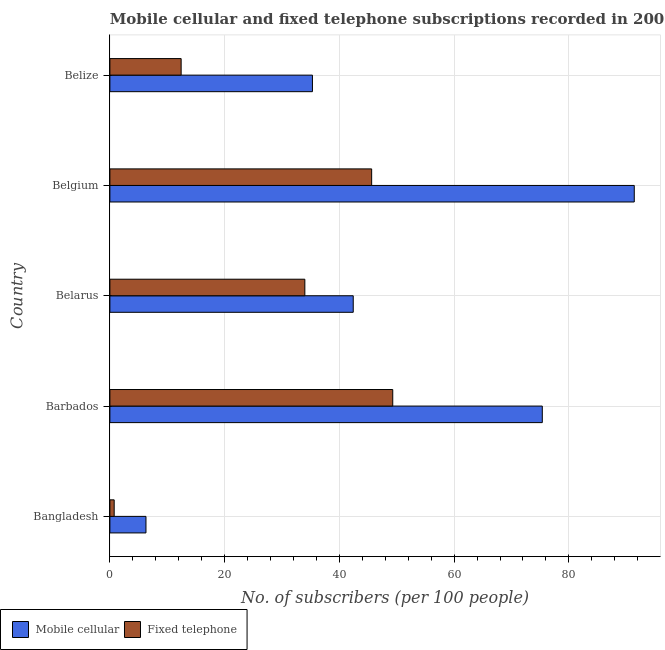How many different coloured bars are there?
Offer a very short reply. 2. Are the number of bars on each tick of the Y-axis equal?
Ensure brevity in your answer.  Yes. How many bars are there on the 4th tick from the bottom?
Keep it short and to the point. 2. What is the label of the 4th group of bars from the top?
Offer a terse response. Barbados. What is the number of fixed telephone subscribers in Bangladesh?
Your response must be concise. 0.75. Across all countries, what is the maximum number of fixed telephone subscribers?
Keep it short and to the point. 49.3. Across all countries, what is the minimum number of fixed telephone subscribers?
Keep it short and to the point. 0.75. In which country was the number of fixed telephone subscribers maximum?
Provide a succinct answer. Barbados. What is the total number of fixed telephone subscribers in the graph?
Your answer should be compact. 142.08. What is the difference between the number of mobile cellular subscribers in Bangladesh and that in Belize?
Provide a succinct answer. -29.02. What is the difference between the number of mobile cellular subscribers in Bangladesh and the number of fixed telephone subscribers in Belarus?
Provide a succinct answer. -27.69. What is the average number of fixed telephone subscribers per country?
Give a very brief answer. 28.42. What is the difference between the number of fixed telephone subscribers and number of mobile cellular subscribers in Belgium?
Your answer should be very brief. -45.77. What is the ratio of the number of mobile cellular subscribers in Bangladesh to that in Belize?
Make the answer very short. 0.18. What is the difference between the highest and the second highest number of fixed telephone subscribers?
Keep it short and to the point. 3.68. What is the difference between the highest and the lowest number of mobile cellular subscribers?
Provide a short and direct response. 85.12. In how many countries, is the number of fixed telephone subscribers greater than the average number of fixed telephone subscribers taken over all countries?
Make the answer very short. 3. Is the sum of the number of fixed telephone subscribers in Barbados and Belgium greater than the maximum number of mobile cellular subscribers across all countries?
Your answer should be compact. Yes. What does the 1st bar from the top in Barbados represents?
Provide a short and direct response. Fixed telephone. What does the 1st bar from the bottom in Belize represents?
Ensure brevity in your answer.  Mobile cellular. How many bars are there?
Offer a very short reply. 10. Are the values on the major ticks of X-axis written in scientific E-notation?
Keep it short and to the point. No. Does the graph contain grids?
Keep it short and to the point. Yes. Where does the legend appear in the graph?
Offer a terse response. Bottom left. How are the legend labels stacked?
Your answer should be very brief. Horizontal. What is the title of the graph?
Provide a short and direct response. Mobile cellular and fixed telephone subscriptions recorded in 2005. What is the label or title of the X-axis?
Offer a terse response. No. of subscribers (per 100 people). What is the No. of subscribers (per 100 people) of Mobile cellular in Bangladesh?
Your answer should be very brief. 6.29. What is the No. of subscribers (per 100 people) in Fixed telephone in Bangladesh?
Keep it short and to the point. 0.75. What is the No. of subscribers (per 100 people) in Mobile cellular in Barbados?
Offer a very short reply. 75.37. What is the No. of subscribers (per 100 people) in Fixed telephone in Barbados?
Keep it short and to the point. 49.3. What is the No. of subscribers (per 100 people) of Mobile cellular in Belarus?
Offer a terse response. 42.42. What is the No. of subscribers (per 100 people) of Fixed telephone in Belarus?
Keep it short and to the point. 33.98. What is the No. of subscribers (per 100 people) of Mobile cellular in Belgium?
Give a very brief answer. 91.4. What is the No. of subscribers (per 100 people) of Fixed telephone in Belgium?
Make the answer very short. 45.63. What is the No. of subscribers (per 100 people) in Mobile cellular in Belize?
Keep it short and to the point. 35.3. What is the No. of subscribers (per 100 people) in Fixed telephone in Belize?
Offer a terse response. 12.42. Across all countries, what is the maximum No. of subscribers (per 100 people) of Mobile cellular?
Your answer should be very brief. 91.4. Across all countries, what is the maximum No. of subscribers (per 100 people) in Fixed telephone?
Your answer should be compact. 49.3. Across all countries, what is the minimum No. of subscribers (per 100 people) of Mobile cellular?
Your answer should be very brief. 6.29. Across all countries, what is the minimum No. of subscribers (per 100 people) of Fixed telephone?
Your response must be concise. 0.75. What is the total No. of subscribers (per 100 people) in Mobile cellular in the graph?
Offer a very short reply. 250.78. What is the total No. of subscribers (per 100 people) of Fixed telephone in the graph?
Your answer should be very brief. 142.08. What is the difference between the No. of subscribers (per 100 people) of Mobile cellular in Bangladesh and that in Barbados?
Your answer should be compact. -69.08. What is the difference between the No. of subscribers (per 100 people) of Fixed telephone in Bangladesh and that in Barbados?
Give a very brief answer. -48.56. What is the difference between the No. of subscribers (per 100 people) in Mobile cellular in Bangladesh and that in Belarus?
Offer a terse response. -36.13. What is the difference between the No. of subscribers (per 100 people) of Fixed telephone in Bangladesh and that in Belarus?
Provide a short and direct response. -33.23. What is the difference between the No. of subscribers (per 100 people) of Mobile cellular in Bangladesh and that in Belgium?
Make the answer very short. -85.12. What is the difference between the No. of subscribers (per 100 people) in Fixed telephone in Bangladesh and that in Belgium?
Offer a very short reply. -44.88. What is the difference between the No. of subscribers (per 100 people) in Mobile cellular in Bangladesh and that in Belize?
Give a very brief answer. -29.02. What is the difference between the No. of subscribers (per 100 people) of Fixed telephone in Bangladesh and that in Belize?
Provide a succinct answer. -11.67. What is the difference between the No. of subscribers (per 100 people) in Mobile cellular in Barbados and that in Belarus?
Provide a short and direct response. 32.95. What is the difference between the No. of subscribers (per 100 people) in Fixed telephone in Barbados and that in Belarus?
Ensure brevity in your answer.  15.32. What is the difference between the No. of subscribers (per 100 people) of Mobile cellular in Barbados and that in Belgium?
Your response must be concise. -16.03. What is the difference between the No. of subscribers (per 100 people) in Fixed telephone in Barbados and that in Belgium?
Offer a very short reply. 3.68. What is the difference between the No. of subscribers (per 100 people) in Mobile cellular in Barbados and that in Belize?
Your response must be concise. 40.07. What is the difference between the No. of subscribers (per 100 people) of Fixed telephone in Barbados and that in Belize?
Offer a very short reply. 36.88. What is the difference between the No. of subscribers (per 100 people) in Mobile cellular in Belarus and that in Belgium?
Your response must be concise. -48.99. What is the difference between the No. of subscribers (per 100 people) in Fixed telephone in Belarus and that in Belgium?
Your answer should be compact. -11.65. What is the difference between the No. of subscribers (per 100 people) in Mobile cellular in Belarus and that in Belize?
Keep it short and to the point. 7.11. What is the difference between the No. of subscribers (per 100 people) in Fixed telephone in Belarus and that in Belize?
Make the answer very short. 21.56. What is the difference between the No. of subscribers (per 100 people) of Mobile cellular in Belgium and that in Belize?
Your answer should be very brief. 56.1. What is the difference between the No. of subscribers (per 100 people) in Fixed telephone in Belgium and that in Belize?
Give a very brief answer. 33.21. What is the difference between the No. of subscribers (per 100 people) in Mobile cellular in Bangladesh and the No. of subscribers (per 100 people) in Fixed telephone in Barbados?
Provide a short and direct response. -43.02. What is the difference between the No. of subscribers (per 100 people) in Mobile cellular in Bangladesh and the No. of subscribers (per 100 people) in Fixed telephone in Belarus?
Ensure brevity in your answer.  -27.69. What is the difference between the No. of subscribers (per 100 people) in Mobile cellular in Bangladesh and the No. of subscribers (per 100 people) in Fixed telephone in Belgium?
Give a very brief answer. -39.34. What is the difference between the No. of subscribers (per 100 people) of Mobile cellular in Bangladesh and the No. of subscribers (per 100 people) of Fixed telephone in Belize?
Provide a succinct answer. -6.13. What is the difference between the No. of subscribers (per 100 people) in Mobile cellular in Barbados and the No. of subscribers (per 100 people) in Fixed telephone in Belarus?
Your answer should be compact. 41.39. What is the difference between the No. of subscribers (per 100 people) of Mobile cellular in Barbados and the No. of subscribers (per 100 people) of Fixed telephone in Belgium?
Offer a terse response. 29.74. What is the difference between the No. of subscribers (per 100 people) of Mobile cellular in Barbados and the No. of subscribers (per 100 people) of Fixed telephone in Belize?
Keep it short and to the point. 62.95. What is the difference between the No. of subscribers (per 100 people) in Mobile cellular in Belarus and the No. of subscribers (per 100 people) in Fixed telephone in Belgium?
Keep it short and to the point. -3.21. What is the difference between the No. of subscribers (per 100 people) of Mobile cellular in Belarus and the No. of subscribers (per 100 people) of Fixed telephone in Belize?
Your answer should be compact. 30. What is the difference between the No. of subscribers (per 100 people) in Mobile cellular in Belgium and the No. of subscribers (per 100 people) in Fixed telephone in Belize?
Offer a very short reply. 78.98. What is the average No. of subscribers (per 100 people) in Mobile cellular per country?
Your answer should be compact. 50.16. What is the average No. of subscribers (per 100 people) of Fixed telephone per country?
Keep it short and to the point. 28.42. What is the difference between the No. of subscribers (per 100 people) of Mobile cellular and No. of subscribers (per 100 people) of Fixed telephone in Bangladesh?
Provide a succinct answer. 5.54. What is the difference between the No. of subscribers (per 100 people) of Mobile cellular and No. of subscribers (per 100 people) of Fixed telephone in Barbados?
Give a very brief answer. 26.07. What is the difference between the No. of subscribers (per 100 people) in Mobile cellular and No. of subscribers (per 100 people) in Fixed telephone in Belarus?
Offer a very short reply. 8.44. What is the difference between the No. of subscribers (per 100 people) in Mobile cellular and No. of subscribers (per 100 people) in Fixed telephone in Belgium?
Give a very brief answer. 45.78. What is the difference between the No. of subscribers (per 100 people) of Mobile cellular and No. of subscribers (per 100 people) of Fixed telephone in Belize?
Keep it short and to the point. 22.89. What is the ratio of the No. of subscribers (per 100 people) of Mobile cellular in Bangladesh to that in Barbados?
Offer a terse response. 0.08. What is the ratio of the No. of subscribers (per 100 people) in Fixed telephone in Bangladesh to that in Barbados?
Offer a terse response. 0.02. What is the ratio of the No. of subscribers (per 100 people) in Mobile cellular in Bangladesh to that in Belarus?
Ensure brevity in your answer.  0.15. What is the ratio of the No. of subscribers (per 100 people) of Fixed telephone in Bangladesh to that in Belarus?
Keep it short and to the point. 0.02. What is the ratio of the No. of subscribers (per 100 people) in Mobile cellular in Bangladesh to that in Belgium?
Your answer should be compact. 0.07. What is the ratio of the No. of subscribers (per 100 people) in Fixed telephone in Bangladesh to that in Belgium?
Provide a succinct answer. 0.02. What is the ratio of the No. of subscribers (per 100 people) in Mobile cellular in Bangladesh to that in Belize?
Your answer should be compact. 0.18. What is the ratio of the No. of subscribers (per 100 people) in Fixed telephone in Bangladesh to that in Belize?
Provide a short and direct response. 0.06. What is the ratio of the No. of subscribers (per 100 people) of Mobile cellular in Barbados to that in Belarus?
Give a very brief answer. 1.78. What is the ratio of the No. of subscribers (per 100 people) in Fixed telephone in Barbados to that in Belarus?
Provide a short and direct response. 1.45. What is the ratio of the No. of subscribers (per 100 people) in Mobile cellular in Barbados to that in Belgium?
Provide a succinct answer. 0.82. What is the ratio of the No. of subscribers (per 100 people) of Fixed telephone in Barbados to that in Belgium?
Ensure brevity in your answer.  1.08. What is the ratio of the No. of subscribers (per 100 people) of Mobile cellular in Barbados to that in Belize?
Give a very brief answer. 2.13. What is the ratio of the No. of subscribers (per 100 people) in Fixed telephone in Barbados to that in Belize?
Make the answer very short. 3.97. What is the ratio of the No. of subscribers (per 100 people) of Mobile cellular in Belarus to that in Belgium?
Make the answer very short. 0.46. What is the ratio of the No. of subscribers (per 100 people) in Fixed telephone in Belarus to that in Belgium?
Provide a succinct answer. 0.74. What is the ratio of the No. of subscribers (per 100 people) of Mobile cellular in Belarus to that in Belize?
Ensure brevity in your answer.  1.2. What is the ratio of the No. of subscribers (per 100 people) in Fixed telephone in Belarus to that in Belize?
Your response must be concise. 2.74. What is the ratio of the No. of subscribers (per 100 people) in Mobile cellular in Belgium to that in Belize?
Your answer should be very brief. 2.59. What is the ratio of the No. of subscribers (per 100 people) in Fixed telephone in Belgium to that in Belize?
Your answer should be compact. 3.67. What is the difference between the highest and the second highest No. of subscribers (per 100 people) of Mobile cellular?
Give a very brief answer. 16.03. What is the difference between the highest and the second highest No. of subscribers (per 100 people) of Fixed telephone?
Ensure brevity in your answer.  3.68. What is the difference between the highest and the lowest No. of subscribers (per 100 people) of Mobile cellular?
Make the answer very short. 85.12. What is the difference between the highest and the lowest No. of subscribers (per 100 people) in Fixed telephone?
Offer a very short reply. 48.56. 